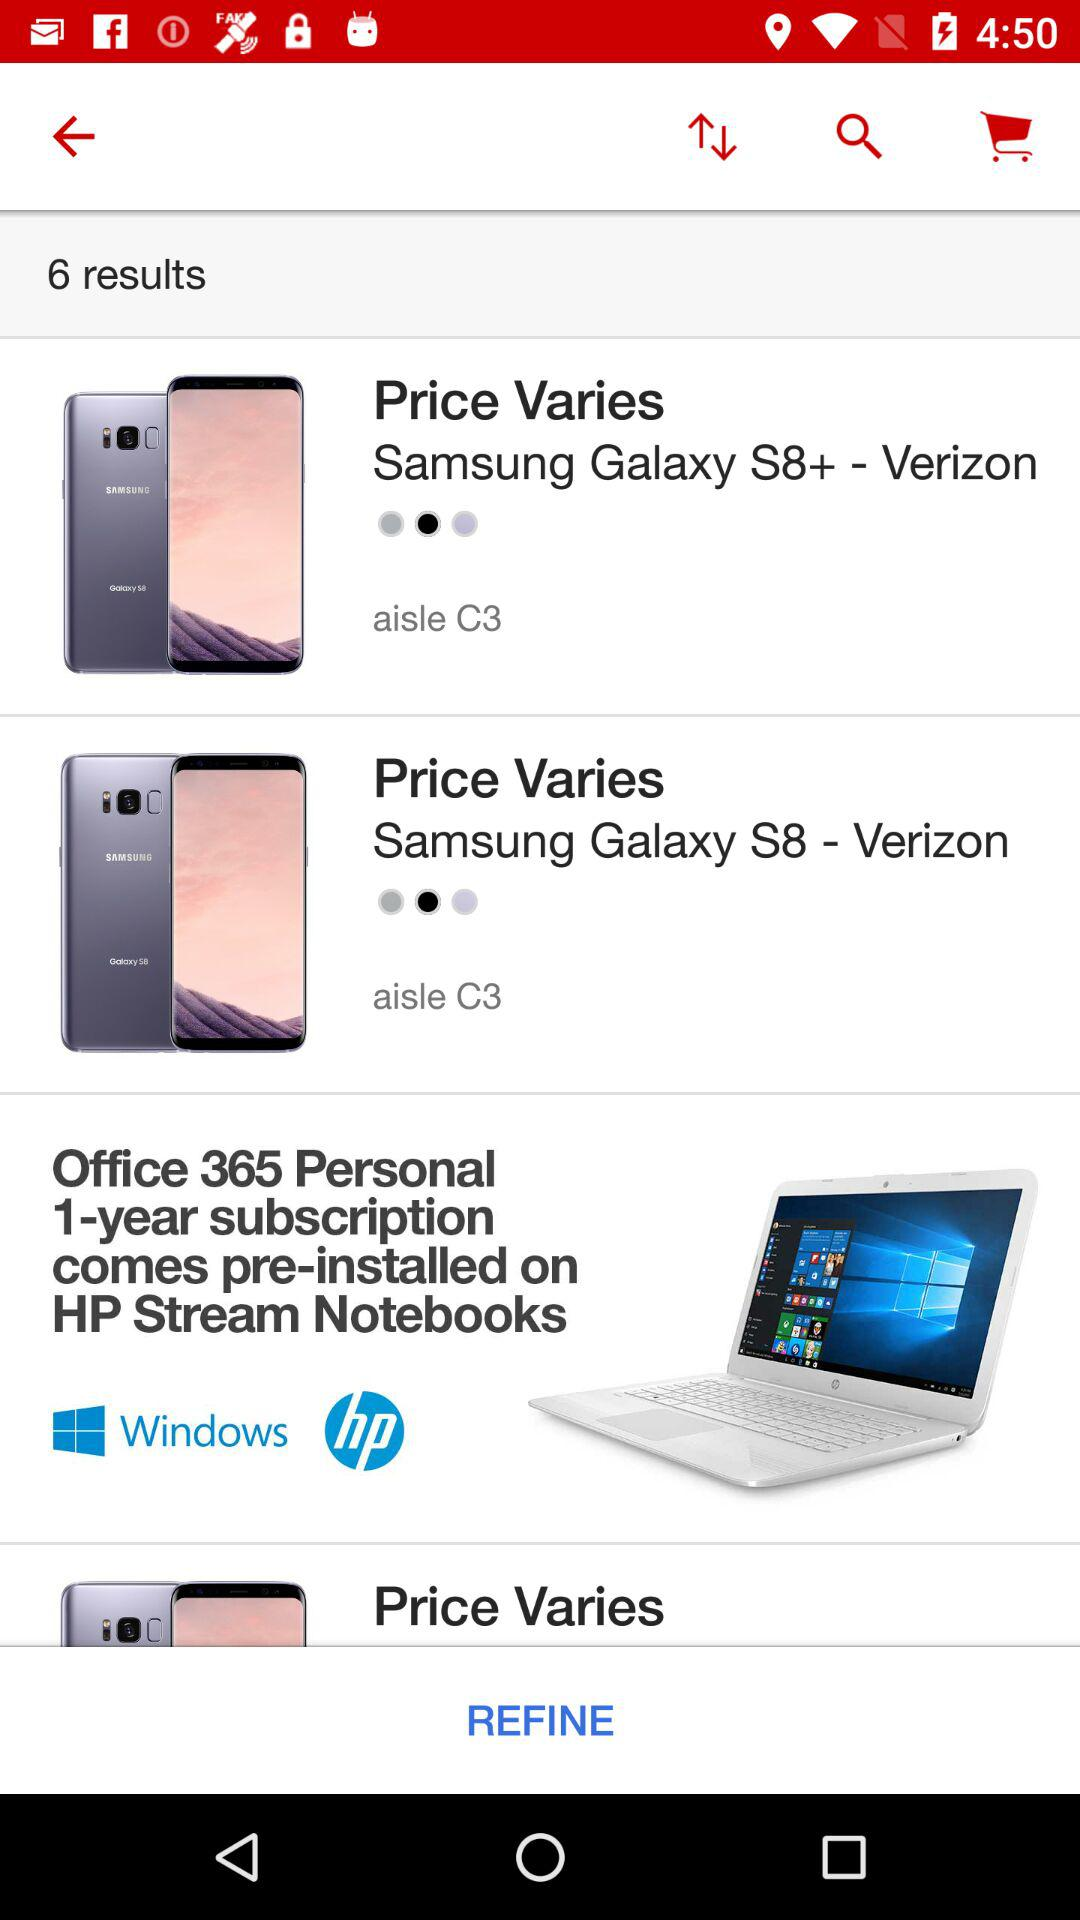How many results are there? There are 6 results. 